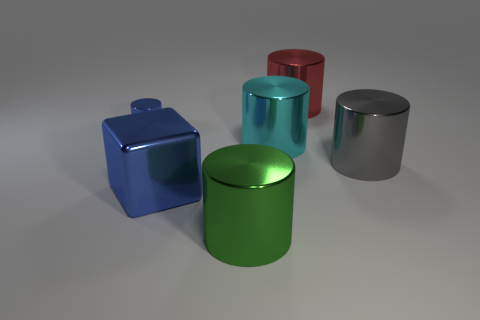Are there any other things that are the same size as the blue shiny cylinder?
Give a very brief answer. No. How many things are large cyan cylinders or large blue metal objects?
Keep it short and to the point. 2. What shape is the other shiny thing that is the same color as the small metallic thing?
Offer a terse response. Cube. What is the size of the cylinder that is to the left of the large cyan object and behind the large green object?
Ensure brevity in your answer.  Small. What number of tiny gray spheres are there?
Offer a very short reply. 0. What number of cylinders are red objects or green things?
Your response must be concise. 2. How many big cylinders are right of the large thing right of the large cylinder behind the cyan cylinder?
Provide a succinct answer. 0. How many other things are the same color as the cube?
Your response must be concise. 1. Are there more big green cylinders in front of the tiny metallic object than big yellow cylinders?
Offer a terse response. Yes. Is the green cylinder made of the same material as the blue block?
Keep it short and to the point. Yes. 